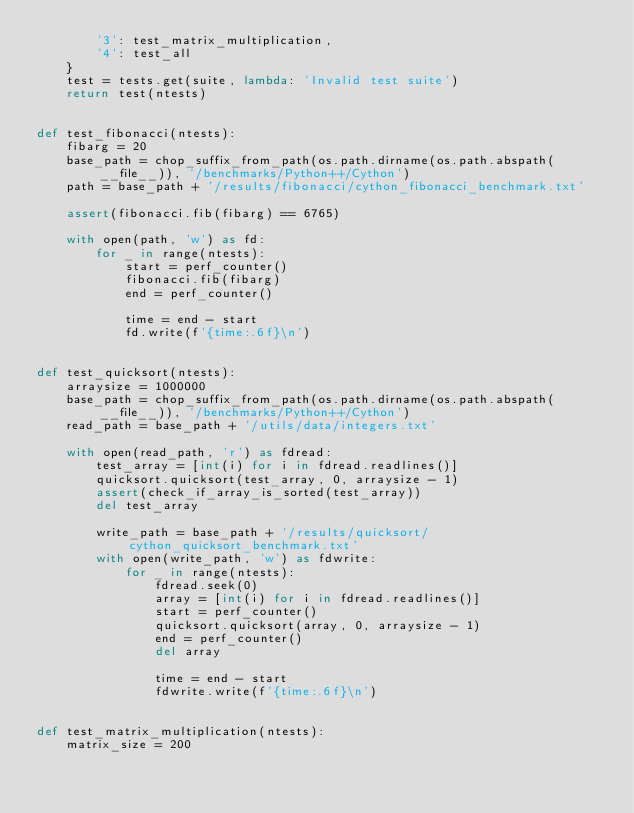<code> <loc_0><loc_0><loc_500><loc_500><_Cython_>        '3': test_matrix_multiplication,
        '4': test_all
    }
    test = tests.get(suite, lambda: 'Invalid test suite')
    return test(ntests)


def test_fibonacci(ntests):
    fibarg = 20
    base_path = chop_suffix_from_path(os.path.dirname(os.path.abspath(__file__)), '/benchmarks/Python++/Cython')
    path = base_path + '/results/fibonacci/cython_fibonacci_benchmark.txt'

    assert(fibonacci.fib(fibarg) == 6765)

    with open(path, 'w') as fd:
        for _ in range(ntests):
            start = perf_counter()
            fibonacci.fib(fibarg)
            end = perf_counter()

            time = end - start
            fd.write(f'{time:.6f}\n')


def test_quicksort(ntests):
    arraysize = 1000000
    base_path = chop_suffix_from_path(os.path.dirname(os.path.abspath(__file__)), '/benchmarks/Python++/Cython')
    read_path = base_path + '/utils/data/integers.txt'

    with open(read_path, 'r') as fdread:
        test_array = [int(i) for i in fdread.readlines()]
        quicksort.quicksort(test_array, 0, arraysize - 1)
        assert(check_if_array_is_sorted(test_array))
        del test_array

        write_path = base_path + '/results/quicksort/cython_quicksort_benchmark.txt'
        with open(write_path, 'w') as fdwrite:
            for _ in range(ntests):
                fdread.seek(0)
                array = [int(i) for i in fdread.readlines()]
                start = perf_counter()
                quicksort.quicksort(array, 0, arraysize - 1)
                end = perf_counter()
                del array
                
                time = end - start
                fdwrite.write(f'{time:.6f}\n')


def test_matrix_multiplication(ntests):
    matrix_size = 200</code> 